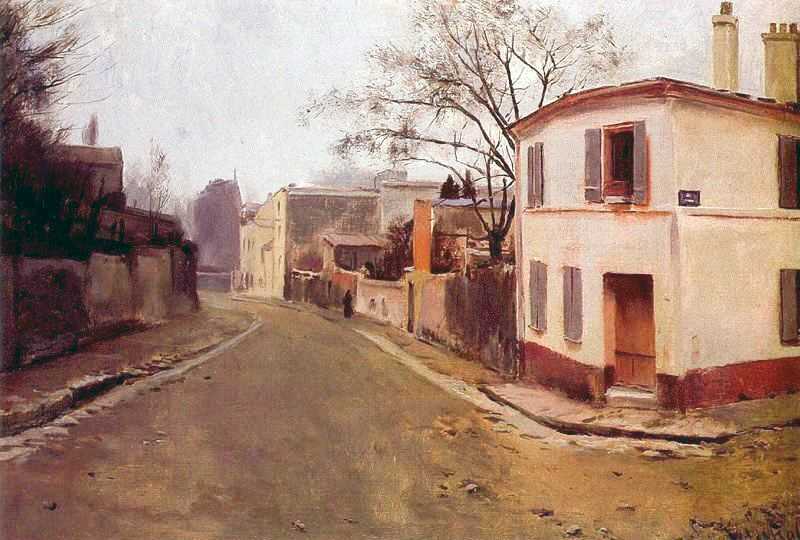What might be happening in the buildings that line the street? Inside the buildings that line the street, various scenes unfold. In the cozy home at the corner with closed shutters, a family is gathered in the living room, enjoying a quiet evening together by the fireplace. Further down, an artist's studio hums with activity as the artist works diligently on a new painting, inspired by the sharegpt4v/same serene streetscape. One of the houses is a small general store, where the shopkeeper is busy taking stock of goods and preparing for the next day's customers. Another building might be a modest inn, where travelers find respite and share stories of their journeys. Each building holds a unique story, contributing to the rich tapestry of life in this peaceful town. 